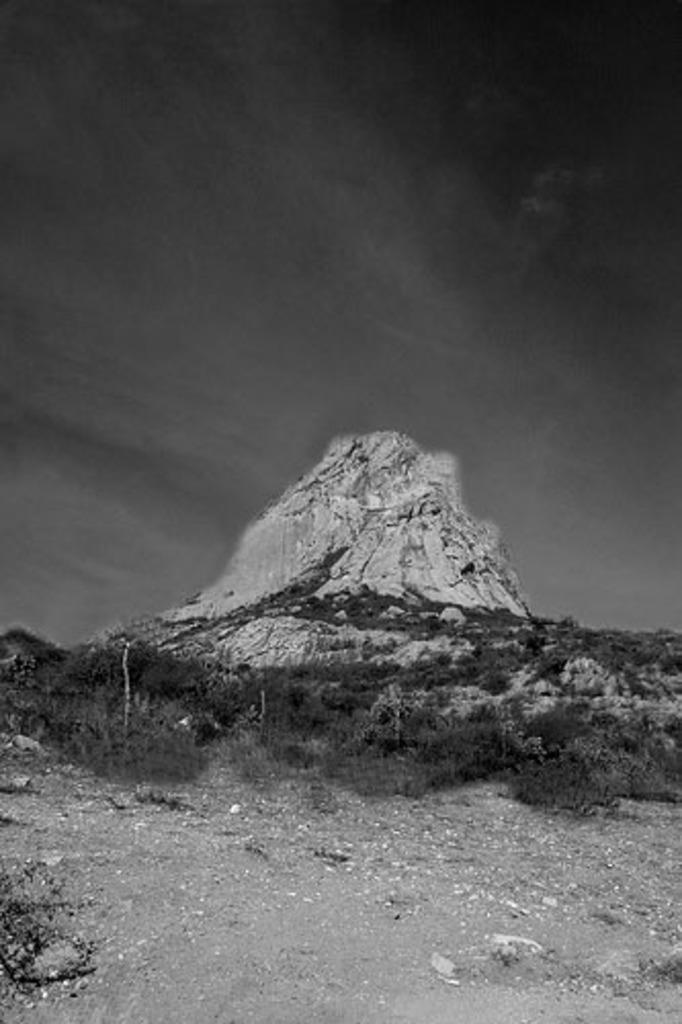What is the color scheme of the image? The image is black and white. What type of vegetation can be seen at the bottom of the image? There is grass at the bottom of the image. What other natural elements are present on the ground in the image? There are trees on the ground in the image. What can be seen in the background of the image? There is a mountain visible in the background of the image, and clouds are present in the sky. What type of pain can be seen on the trees in the image? There is no indication of pain on the trees in the image; they appear to be healthy and natural. 